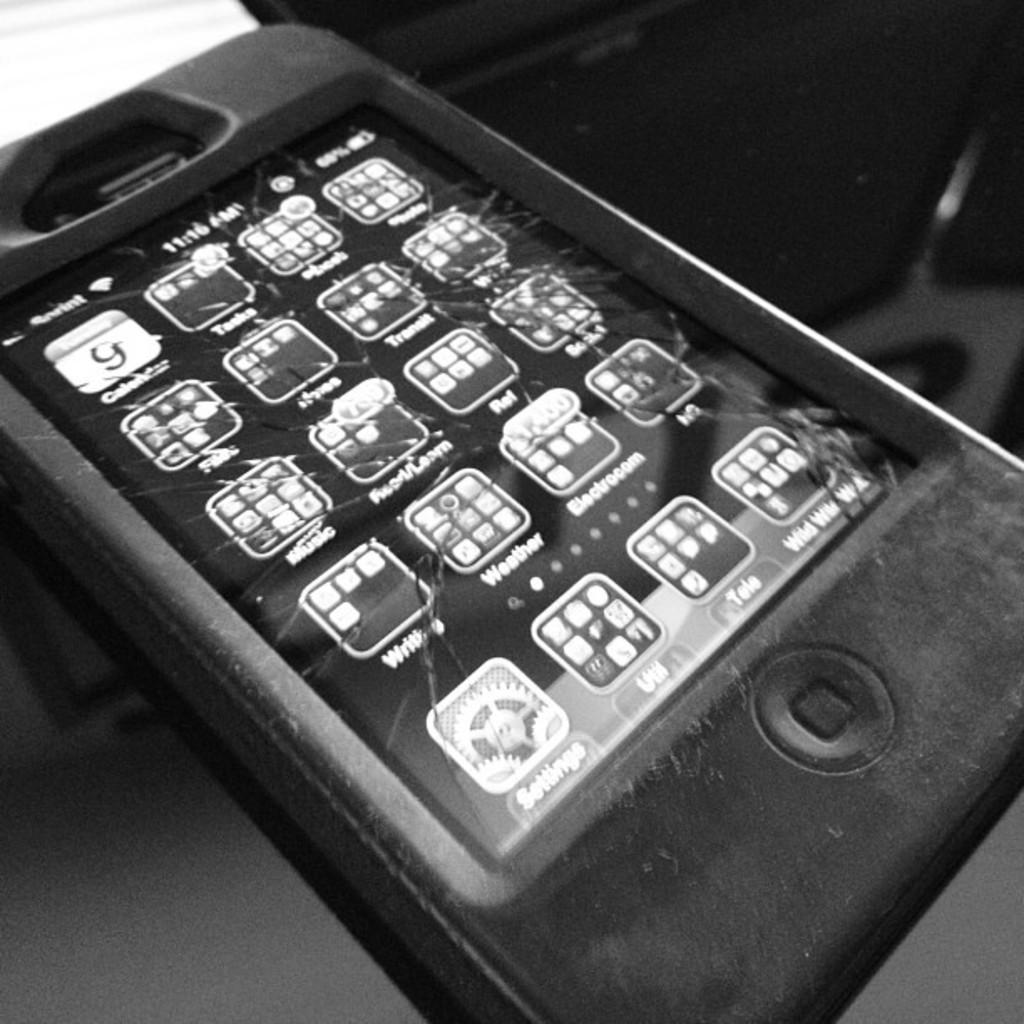<image>
Summarize the visual content of the image. A cracked iPhone that is connected to sprint. 